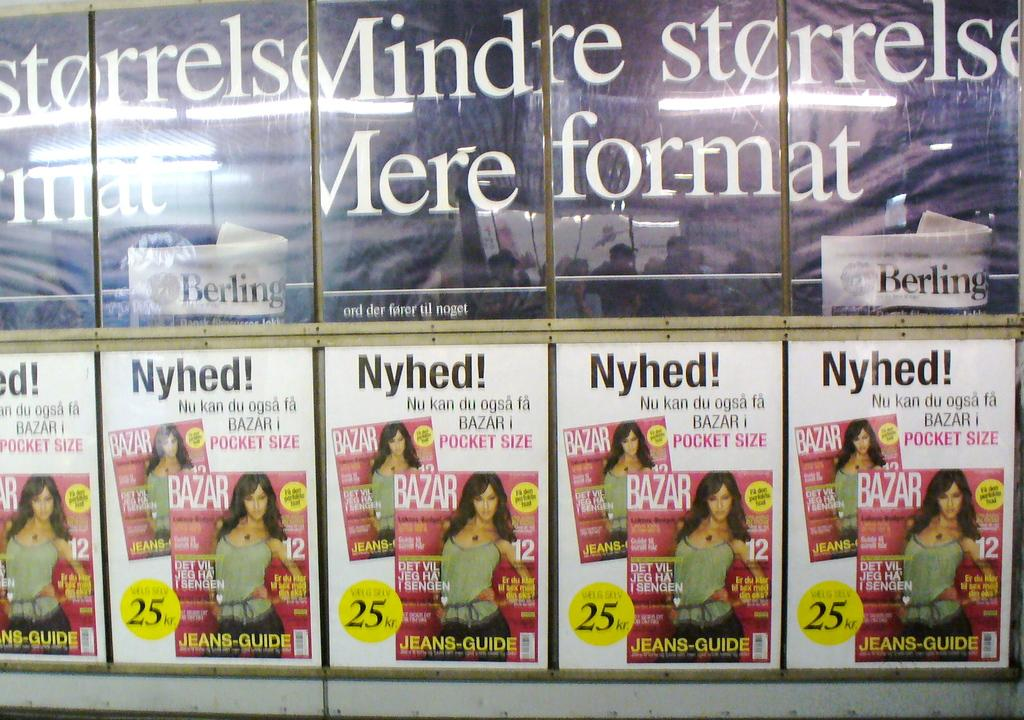<image>
Create a compact narrative representing the image presented. A set of five bazar magazines for women side by side. 